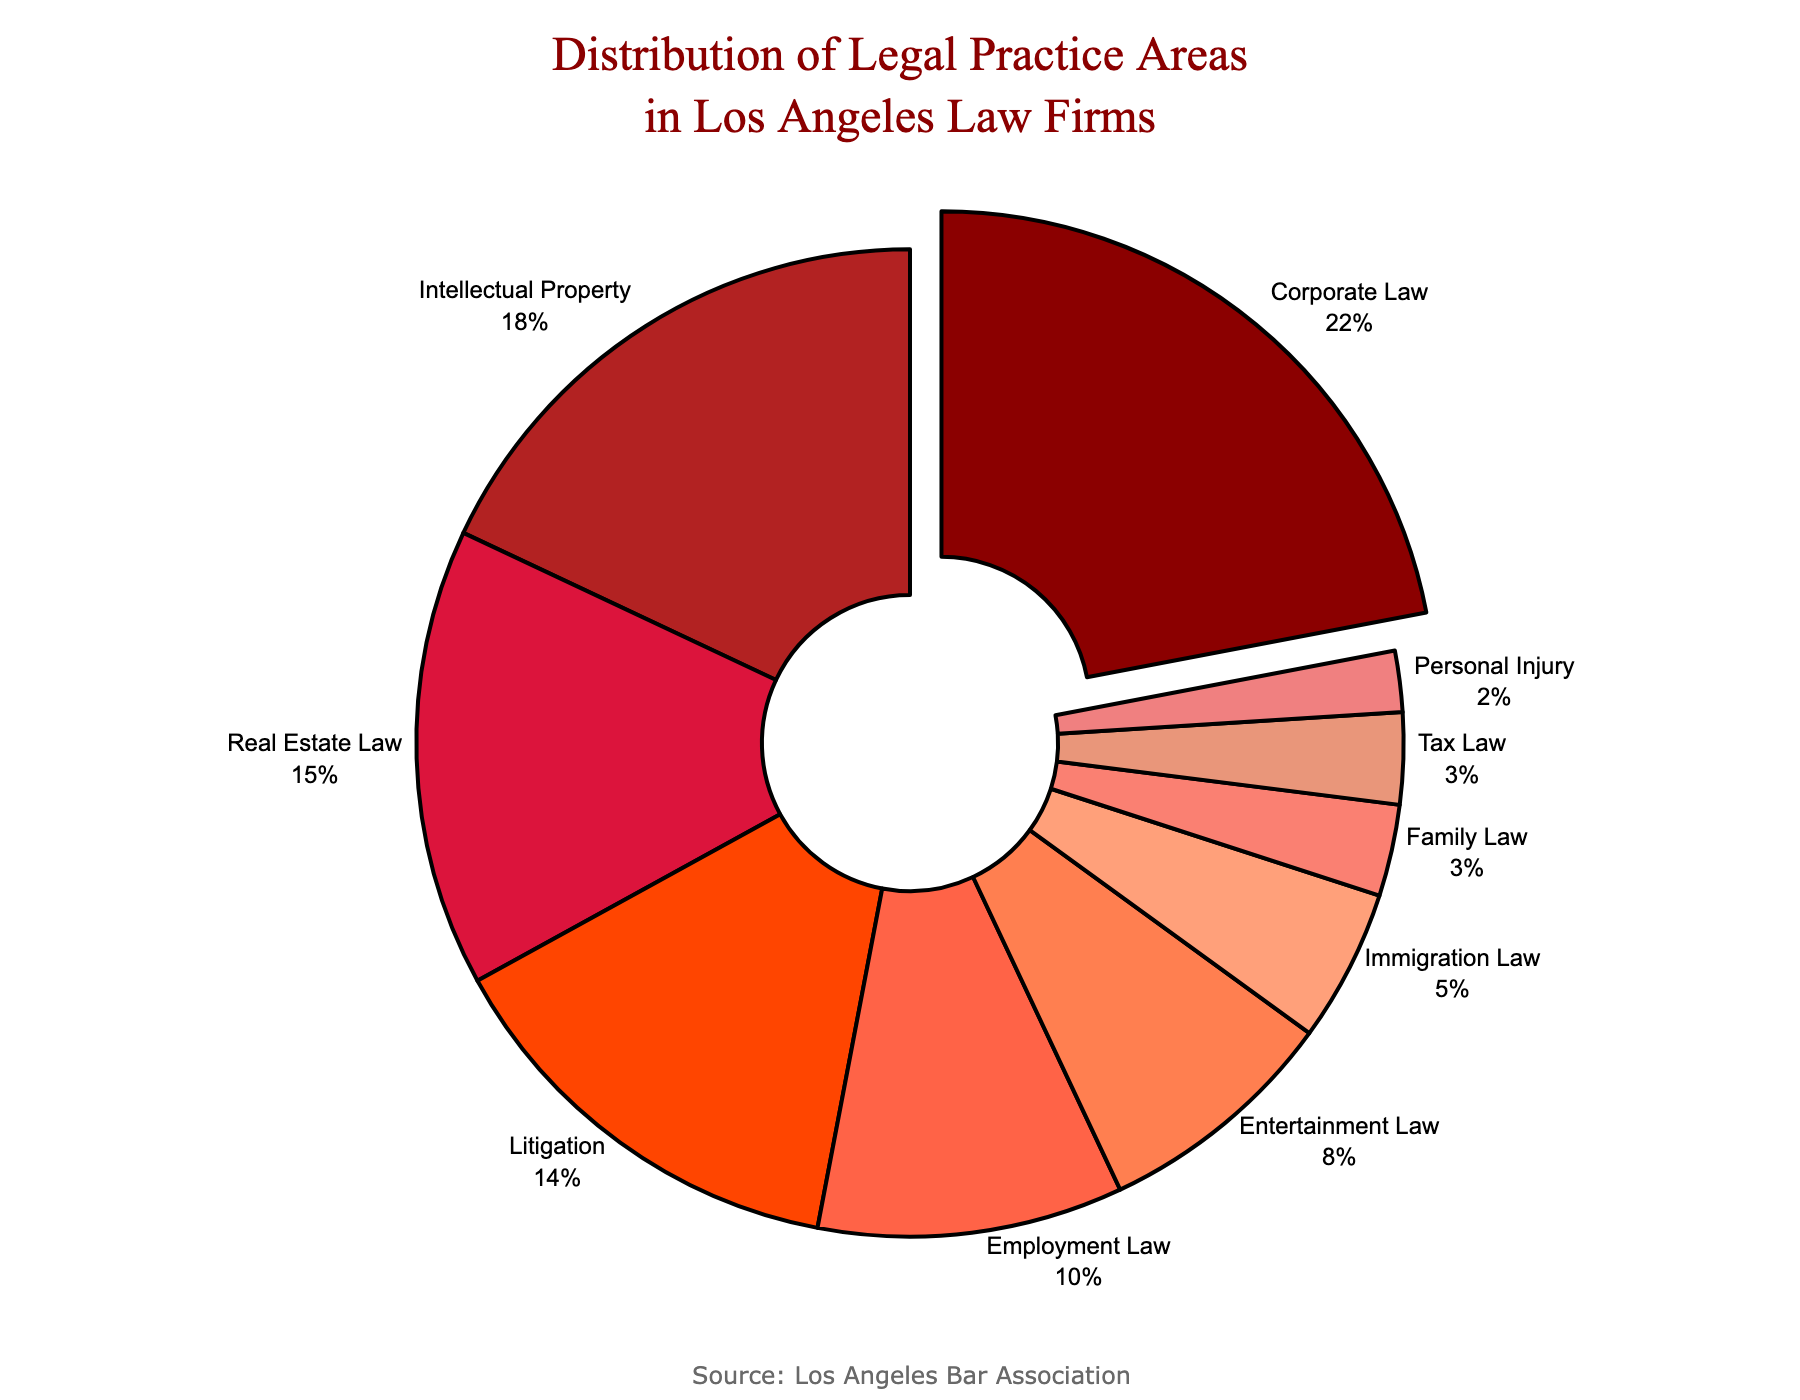Which practice area has the highest percentage? By observing the pie chart, we can see which segment is pulled out. The largest segment pulled out represents the highest percentage, which belongs to Corporate Law.
Answer: Corporate Law What is the combined percentage of Real Estate Law and Employment Law? First, locate the segments for Real Estate Law and Employment Law. Add their percentages: Real Estate Law (15%) + Employment Law (10%) = 25%.
Answer: 25% Is the percentage of Intellectual Property higher than Litigation? Compare the percentage values of Intellectual Property (18%) and Litigation (14%) on the chart. Intellectual Property is indeed higher.
Answer: Yes Which practice areas have a percentage lower than 5%? Identify the segments with percentages less than 5%: Immigration Law (5%), Family Law (3%), Tax Law (3%), and Personal Injury (2%). Only Family Law, Tax Law, and Personal Injury have less than 5%.
Answer: Family Law, Tax Law, Personal Injury By how many percentage points is Corporate Law larger than Entertainment Law? Find the percentage difference between Corporate Law (22%) and Entertainment Law (8%). Subtract Entertainment Law's percentage from Corporate Law’s: 22% - 8% = 14%.
Answer: 14% Which practice area represents the smallest percentage? Look for the smallest segment in the pie chart, which represents Personal Injury at 2%.
Answer: Personal Injury What is the total percentage of practice areas not related to Intellectual Property, Corporate Law, and Litigation? Subtract the combined percentages of Intellectual Property (18%), Corporate Law (22%), and Litigation (14%) from 100%: 100% - (18% + 22% + 14%) = 100% - 54% = 46%.
Answer: 46% Among the fields with more than 10%, which one has the second-highest percentage? Identify the segments with more than 10%: Corporate Law (22%), Intellectual Property (18%), Real Estate Law (15%), and Litigation (14%). The second-highest among them is Intellectual Property at 18%.
Answer: Intellectual Property 